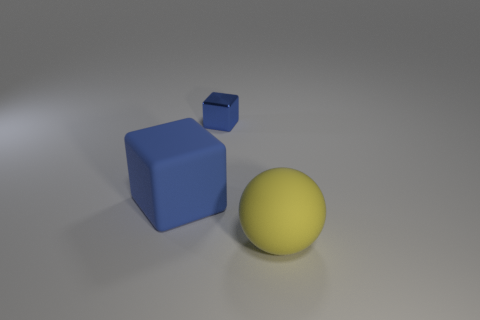Is the color of the tiny block the same as the big cube?
Provide a succinct answer. Yes. What color is the thing that is both behind the large sphere and right of the big blue matte cube?
Give a very brief answer. Blue. Are there any yellow balls left of the metal block?
Make the answer very short. No. There is a large matte thing behind the big yellow thing; how many tiny blue things are behind it?
Offer a terse response. 1. What size is the blue thing that is the same material as the large yellow ball?
Ensure brevity in your answer.  Large. What size is the yellow matte ball?
Give a very brief answer. Large. Is the material of the tiny blue cube the same as the big sphere?
Your answer should be very brief. No. What number of spheres are either tiny gray things or big things?
Your answer should be compact. 1. What color is the large thing that is on the right side of the matte thing that is left of the yellow object?
Your answer should be very brief. Yellow. There is another metallic block that is the same color as the large block; what size is it?
Provide a short and direct response. Small. 